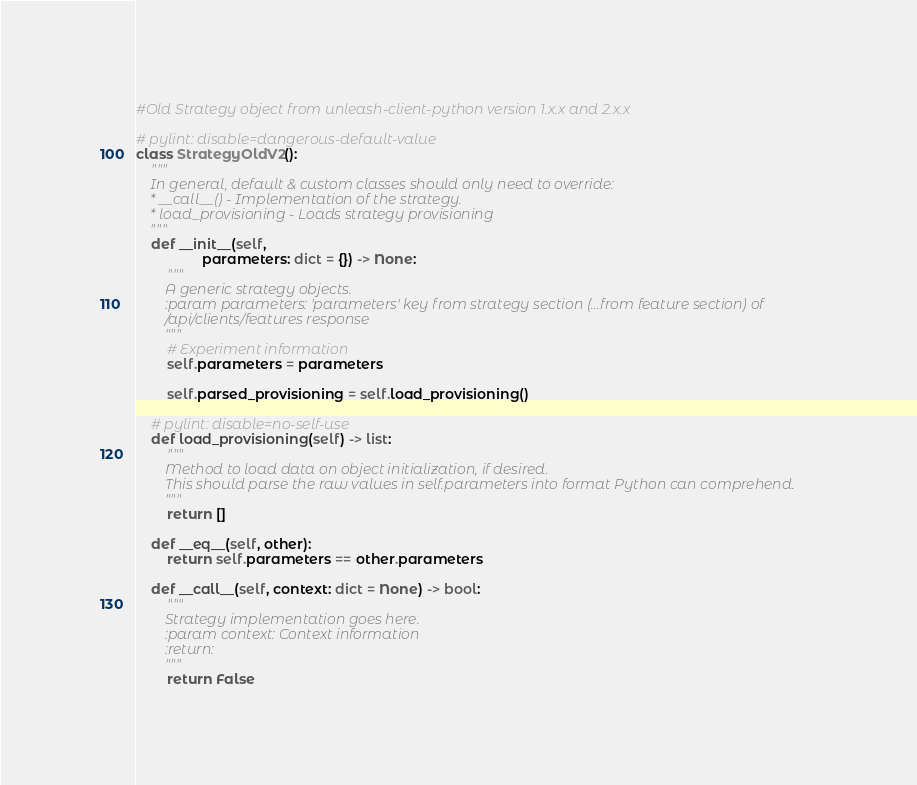<code> <loc_0><loc_0><loc_500><loc_500><_Python_>#Old Strategy object from unleash-client-python version 1.x.x and 2.x.x

# pylint: disable=dangerous-default-value
class StrategyOldV2():
    """
    In general, default & custom classes should only need to override:
    * __call__() - Implementation of the strategy.
    * load_provisioning - Loads strategy provisioning
    """
    def __init__(self,
                 parameters: dict = {}) -> None:
        """
        A generic strategy objects.
        :param parameters: 'parameters' key from strategy section (...from feature section) of
        /api/clients/features response
        """
        # Experiment information
        self.parameters = parameters

        self.parsed_provisioning = self.load_provisioning()

    # pylint: disable=no-self-use
    def load_provisioning(self) -> list:
        """
        Method to load data on object initialization, if desired.
        This should parse the raw values in self.parameters into format Python can comprehend.
        """
        return []

    def __eq__(self, other):
        return self.parameters == other.parameters

    def __call__(self, context: dict = None) -> bool:
        """
        Strategy implementation goes here.
        :param context: Context information
        :return:
        """
        return False
</code> 